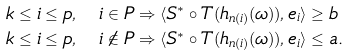Convert formula to latex. <formula><loc_0><loc_0><loc_500><loc_500>& k \leq i \leq p , \quad i \in P \Rightarrow \langle S ^ { * } \circ T ( h _ { n ( i ) } ( \omega ) ) , e _ { i } \rangle \geq b \\ & k \leq i \leq p , \quad i \notin P \Rightarrow \langle S ^ { * } \circ T ( h _ { n ( i ) } ( \omega ) ) , e _ { i } \rangle \leq a .</formula> 